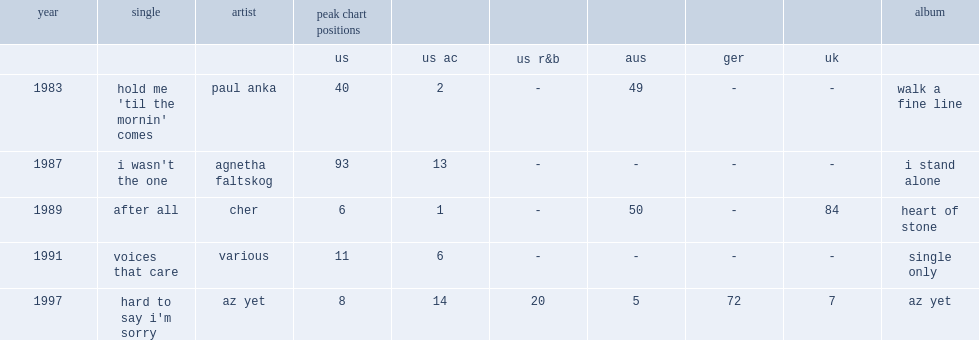What is the peak chart position of peter cetera debuted single "hold me 'til the mornin' comes" in the us? 40.0. 